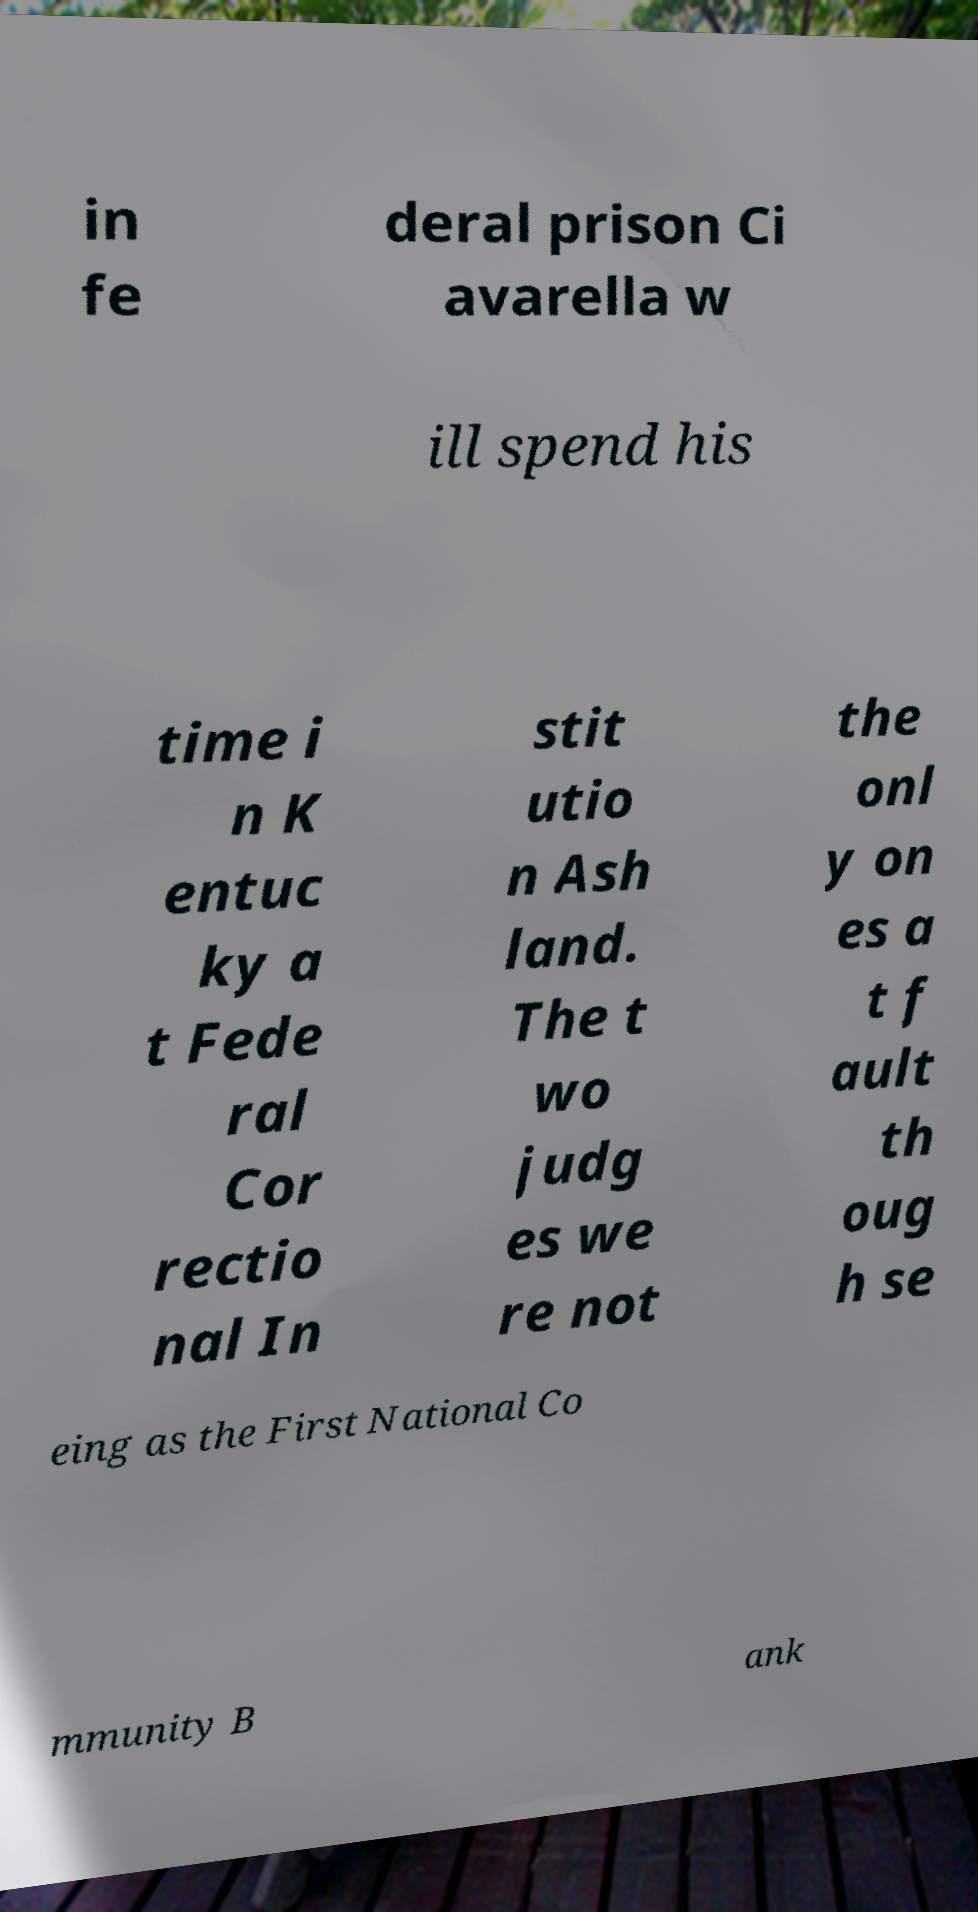Please read and relay the text visible in this image. What does it say? in fe deral prison Ci avarella w ill spend his time i n K entuc ky a t Fede ral Cor rectio nal In stit utio n Ash land. The t wo judg es we re not the onl y on es a t f ault th oug h se eing as the First National Co mmunity B ank 